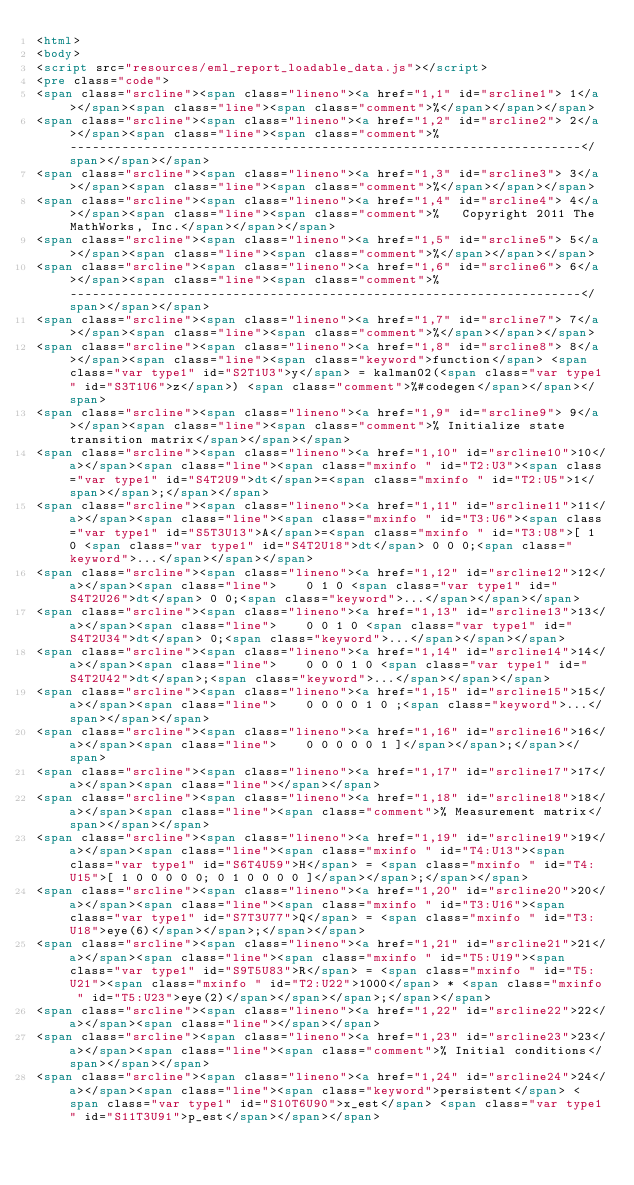<code> <loc_0><loc_0><loc_500><loc_500><_HTML_><html>
<body>
<script src="resources/eml_report_loadable_data.js"></script>
<pre class="code">
<span class="srcline"><span class="lineno"><a href="1,1" id="srcline1"> 1</a></span><span class="line"><span class="comment">%</span></span></span>
<span class="srcline"><span class="lineno"><a href="1,2" id="srcline2"> 2</a></span><span class="line"><span class="comment">%   ---------------------------------------------------------------------</span></span></span>
<span class="srcline"><span class="lineno"><a href="1,3" id="srcline3"> 3</a></span><span class="line"><span class="comment">%</span></span></span>
<span class="srcline"><span class="lineno"><a href="1,4" id="srcline4"> 4</a></span><span class="line"><span class="comment">%   Copyright 2011 The MathWorks, Inc.</span></span></span>
<span class="srcline"><span class="lineno"><a href="1,5" id="srcline5"> 5</a></span><span class="line"><span class="comment">%</span></span></span>
<span class="srcline"><span class="lineno"><a href="1,6" id="srcline6"> 6</a></span><span class="line"><span class="comment">%   ---------------------------------------------------------------------</span></span></span>
<span class="srcline"><span class="lineno"><a href="1,7" id="srcline7"> 7</a></span><span class="line"><span class="comment">%</span></span></span>
<span class="srcline"><span class="lineno"><a href="1,8" id="srcline8"> 8</a></span><span class="line"><span class="keyword">function</span> <span class="var type1" id="S2T1U3">y</span> = kalman02(<span class="var type1" id="S3T1U6">z</span>) <span class="comment">%#codegen</span></span></span>
<span class="srcline"><span class="lineno"><a href="1,9" id="srcline9"> 9</a></span><span class="line"><span class="comment">% Initialize state transition matrix</span></span></span>
<span class="srcline"><span class="lineno"><a href="1,10" id="srcline10">10</a></span><span class="line"><span class="mxinfo " id="T2:U3"><span class="var type1" id="S4T2U9">dt</span>=<span class="mxinfo " id="T2:U5">1</span></span>;</span></span>
<span class="srcline"><span class="lineno"><a href="1,11" id="srcline11">11</a></span><span class="line"><span class="mxinfo " id="T3:U6"><span class="var type1" id="S5T3U13">A</span>=<span class="mxinfo " id="T3:U8">[ 1 0 <span class="var type1" id="S4T2U18">dt</span> 0 0 0;<span class="keyword">...</span></span></span>
<span class="srcline"><span class="lineno"><a href="1,12" id="srcline12">12</a></span><span class="line">    0 1 0 <span class="var type1" id="S4T2U26">dt</span> 0 0;<span class="keyword">...</span></span></span>
<span class="srcline"><span class="lineno"><a href="1,13" id="srcline13">13</a></span><span class="line">    0 0 1 0 <span class="var type1" id="S4T2U34">dt</span> 0;<span class="keyword">...</span></span></span>
<span class="srcline"><span class="lineno"><a href="1,14" id="srcline14">14</a></span><span class="line">    0 0 0 1 0 <span class="var type1" id="S4T2U42">dt</span>;<span class="keyword">...</span></span></span>
<span class="srcline"><span class="lineno"><a href="1,15" id="srcline15">15</a></span><span class="line">    0 0 0 0 1 0 ;<span class="keyword">...</span></span></span>
<span class="srcline"><span class="lineno"><a href="1,16" id="srcline16">16</a></span><span class="line">    0 0 0 0 0 1 ]</span></span>;</span></span>
<span class="srcline"><span class="lineno"><a href="1,17" id="srcline17">17</a></span><span class="line"></span></span>
<span class="srcline"><span class="lineno"><a href="1,18" id="srcline18">18</a></span><span class="line"><span class="comment">% Measurement matrix</span></span></span>
<span class="srcline"><span class="lineno"><a href="1,19" id="srcline19">19</a></span><span class="line"><span class="mxinfo " id="T4:U13"><span class="var type1" id="S6T4U59">H</span> = <span class="mxinfo " id="T4:U15">[ 1 0 0 0 0 0; 0 1 0 0 0 0 ]</span></span>;</span></span>
<span class="srcline"><span class="lineno"><a href="1,20" id="srcline20">20</a></span><span class="line"><span class="mxinfo " id="T3:U16"><span class="var type1" id="S7T3U77">Q</span> = <span class="mxinfo " id="T3:U18">eye(6)</span></span>;</span></span>
<span class="srcline"><span class="lineno"><a href="1,21" id="srcline21">21</a></span><span class="line"><span class="mxinfo " id="T5:U19"><span class="var type1" id="S9T5U83">R</span> = <span class="mxinfo " id="T5:U21"><span class="mxinfo " id="T2:U22">1000</span> * <span class="mxinfo " id="T5:U23">eye(2)</span></span></span>;</span></span>
<span class="srcline"><span class="lineno"><a href="1,22" id="srcline22">22</a></span><span class="line"></span></span>
<span class="srcline"><span class="lineno"><a href="1,23" id="srcline23">23</a></span><span class="line"><span class="comment">% Initial conditions</span></span></span>
<span class="srcline"><span class="lineno"><a href="1,24" id="srcline24">24</a></span><span class="line"><span class="keyword">persistent</span> <span class="var type1" id="S10T6U90">x_est</span> <span class="var type1" id="S11T3U91">p_est</span></span></span></code> 